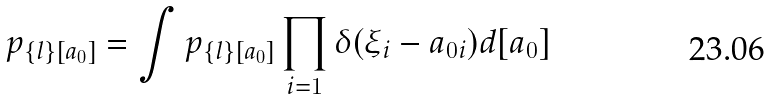Convert formula to latex. <formula><loc_0><loc_0><loc_500><loc_500>p _ { \{ l \} [ { a } _ { 0 } ] } = \int p _ { \{ l \} [ { a } _ { 0 } ] } \prod _ { i = 1 } \delta ( \xi _ { i } - a _ { 0 i } ) d [ { a } _ { 0 } ]</formula> 